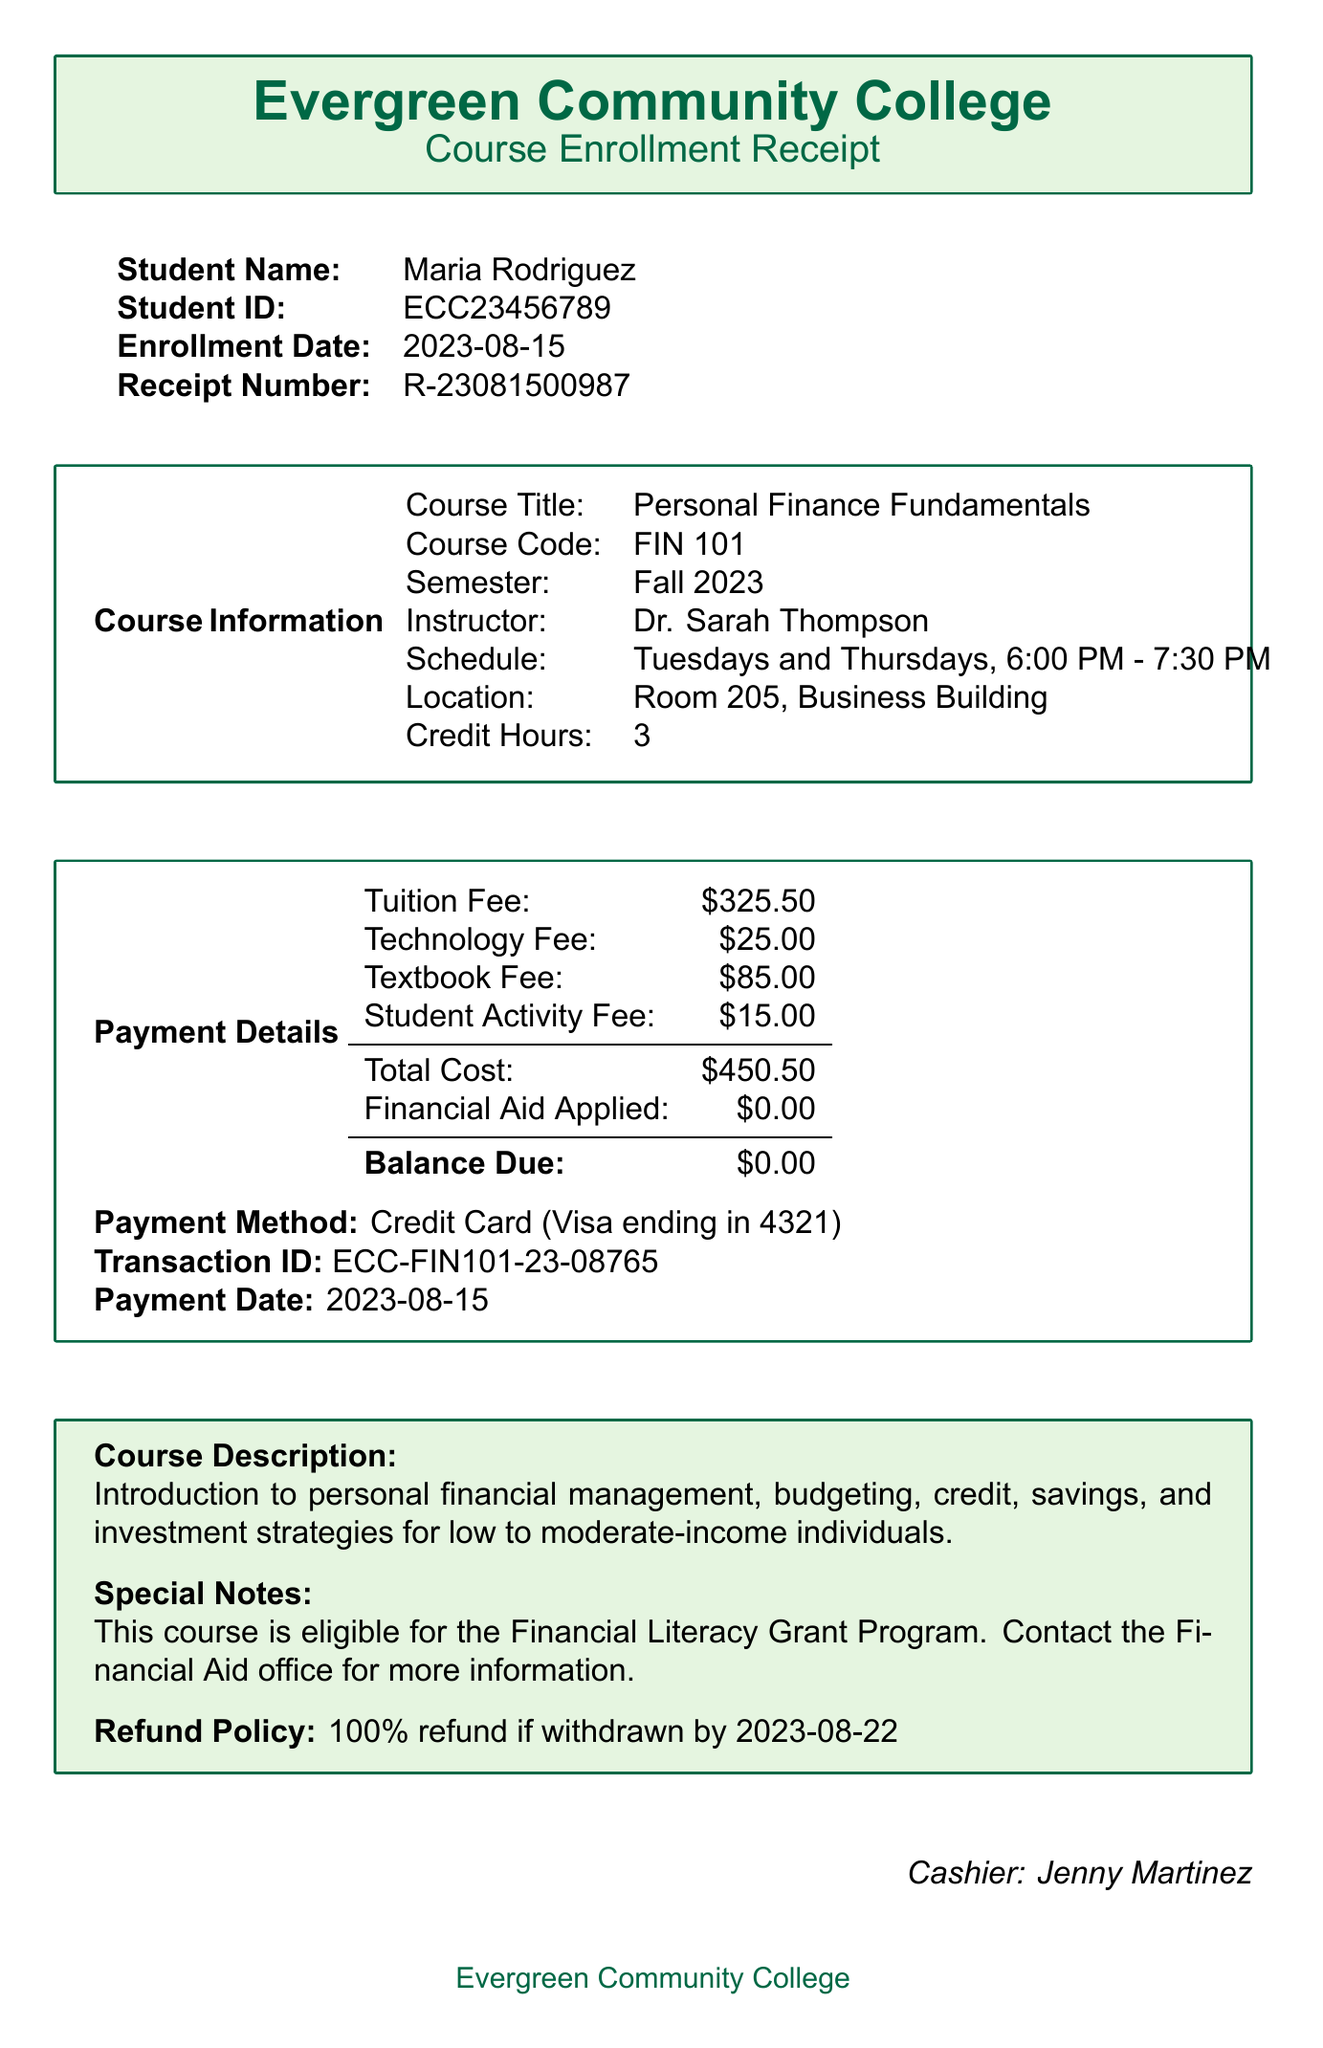What is the course title? The course title is specified in the document under Course Information.
Answer: Personal Finance Fundamentals Who is the instructor for the course? The instructor's name is listed under Course Information.
Answer: Dr. Sarah Thompson What is the total cost of the course? The total cost is provided in the Payment Details section of the document.
Answer: $450.50 When is the enrollment date? The enrollment date is mentioned at the top of the receipt, under the student information.
Answer: 2023-08-15 What is the refund policy? The refund policy is described in the Special Notes section of the document.
Answer: 100% refund if withdrawn by 2023-08-22 What payment method was used? The payment method is included in the Payment Details section.
Answer: Credit Card (Visa ending in 4321) How many credit hours is the course worth? The number of credit hours is found under Course Information.
Answer: 3 What is the balance due? The balance due is shown in the Payment Details section.
Answer: $0.00 What is the student ID? The student ID is provided in the student information section at the beginning of the document.
Answer: ECC23456789 